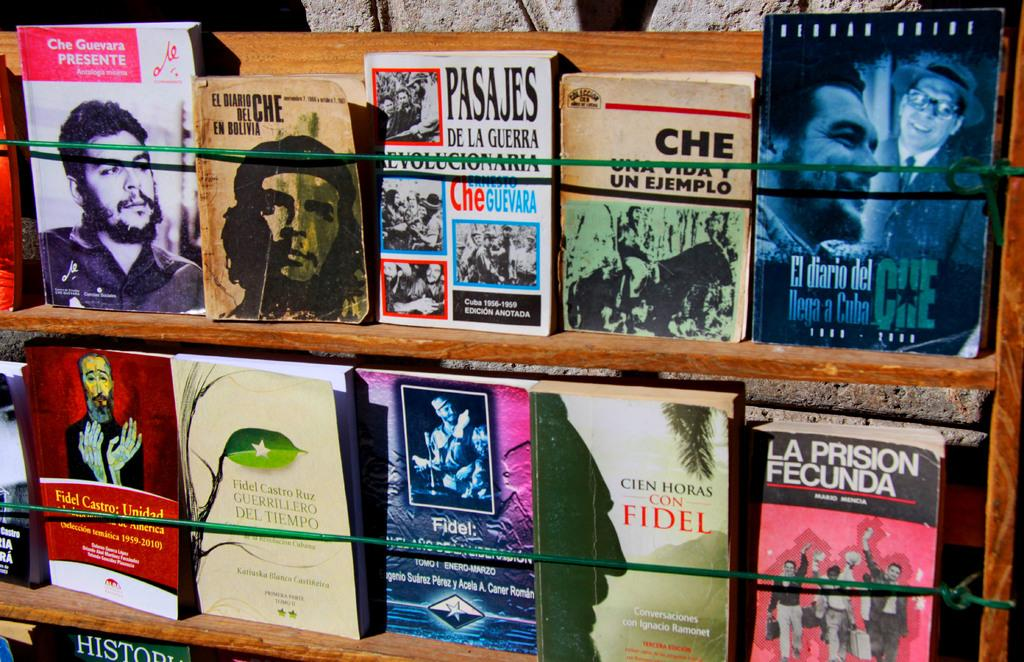What objects can be seen in the image? There are books in the image. How are the books arranged? The books are placed in wooden racks. What can be seen in the background of the image? There is a wall in the background of the image. What type of poles are present in the image? There are thin green color iron poles in the image. What type of fruit is growing on the wall in the image? There is no fruit growing on the wall in the image; the wall is in the background and does not have any visible plants or fruit. 